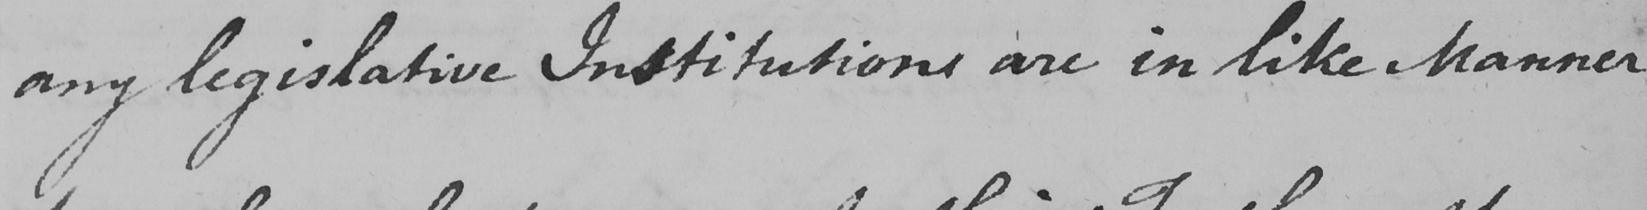Transcribe the text shown in this historical manuscript line. any legislative Institutions are in like Manner 